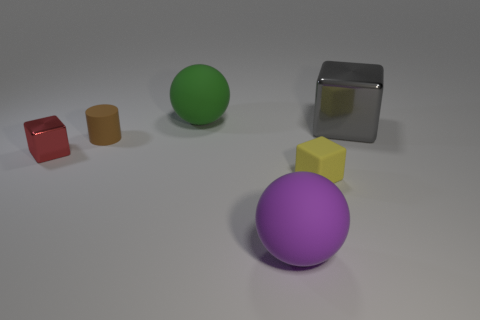Add 1 small red balls. How many objects exist? 7 Subtract all cylinders. How many objects are left? 5 Add 2 red matte blocks. How many red matte blocks exist? 2 Subtract 1 yellow blocks. How many objects are left? 5 Subtract all small shiny things. Subtract all large green rubber spheres. How many objects are left? 4 Add 1 large things. How many large things are left? 4 